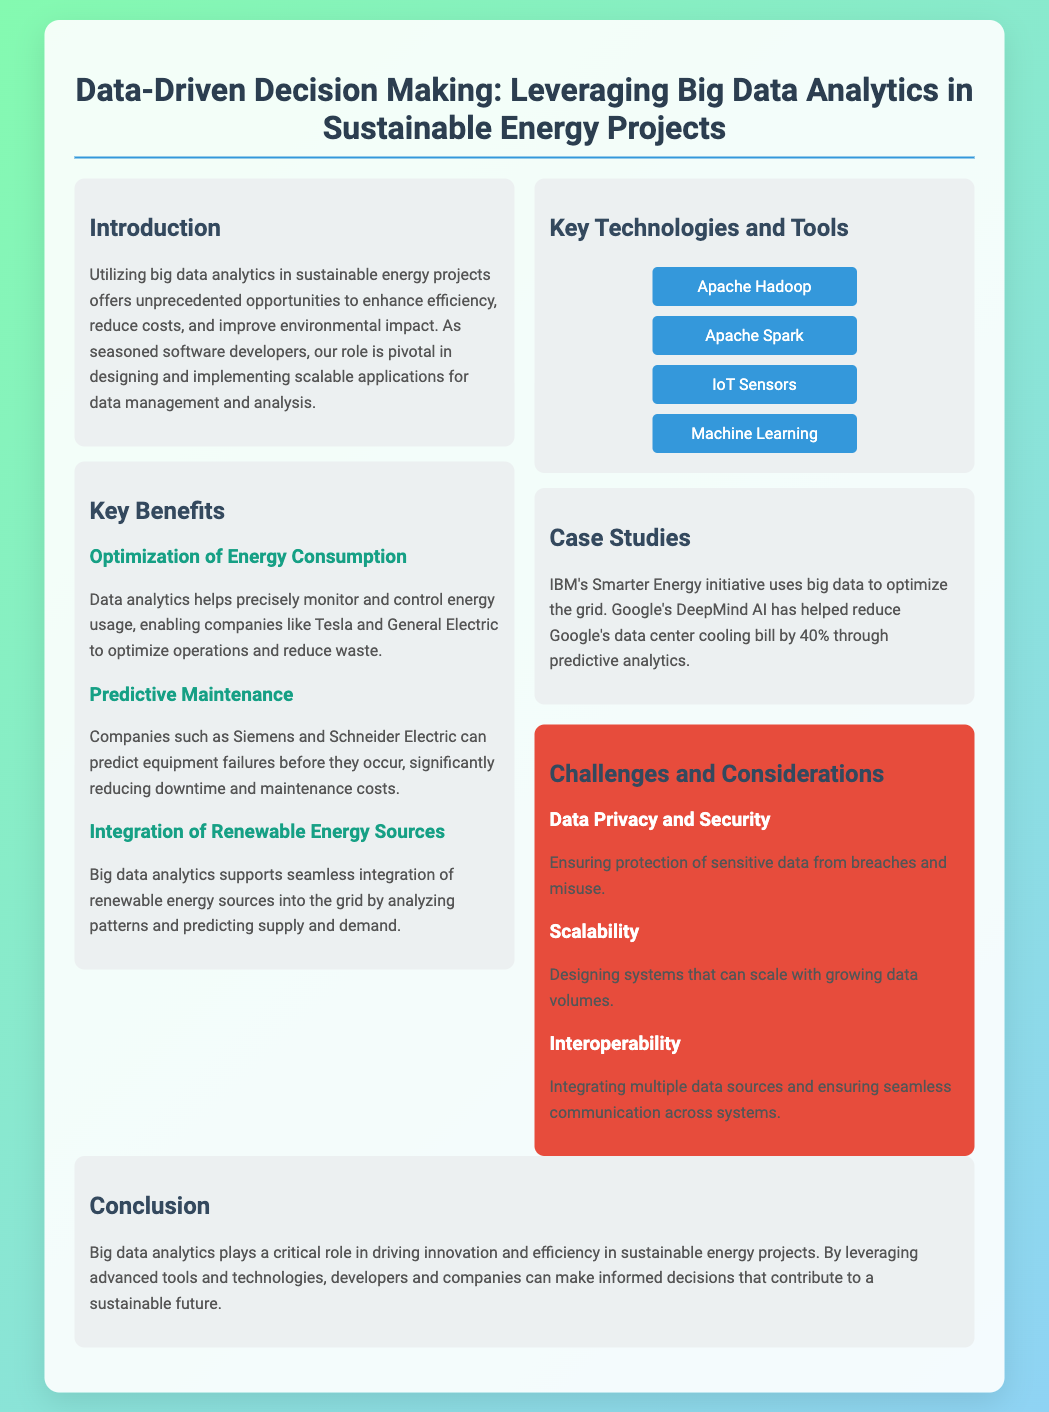What is the title of the presentation? The title is stated prominently at the top of the document, indicating the focus of the content.
Answer: Data-Driven Decision Making: Leveraging Big Data Analytics in Sustainable Energy Projects What is one key benefit of data analytics? The document lists specific benefits under the "Key Benefits" section, highlighting various advantages.
Answer: Optimization of Energy Consumption Which company used predictive maintenance according to the document? The document mentions companies that utilize predictive maintenance under the "Key Benefits" section.
Answer: Siemens What technology supports the integration of renewable energy sources? The document outlines specific roles of big data analytics in energy projects, indicating specific technologies.
Answer: Big data analytics What is one challenge mentioned regarding data management? The challenges are outlined in a dedicated section, providing insights into issues that may arise.
Answer: Data Privacy and Security How much did Google reduce its data center cooling bill by using predictive analytics? The specific percentage reduction is mentioned as a part of the case studies provided.
Answer: 40% What advanced technology is listed among the key technologies and tools? The document provides a list of technologies crucial for data analytics in sustainable energy projects.
Answer: Machine Learning Which initiative uses big data to optimize the grid? The document provides information about various case studies related to the use of big data.
Answer: IBM's Smarter Energy initiative 